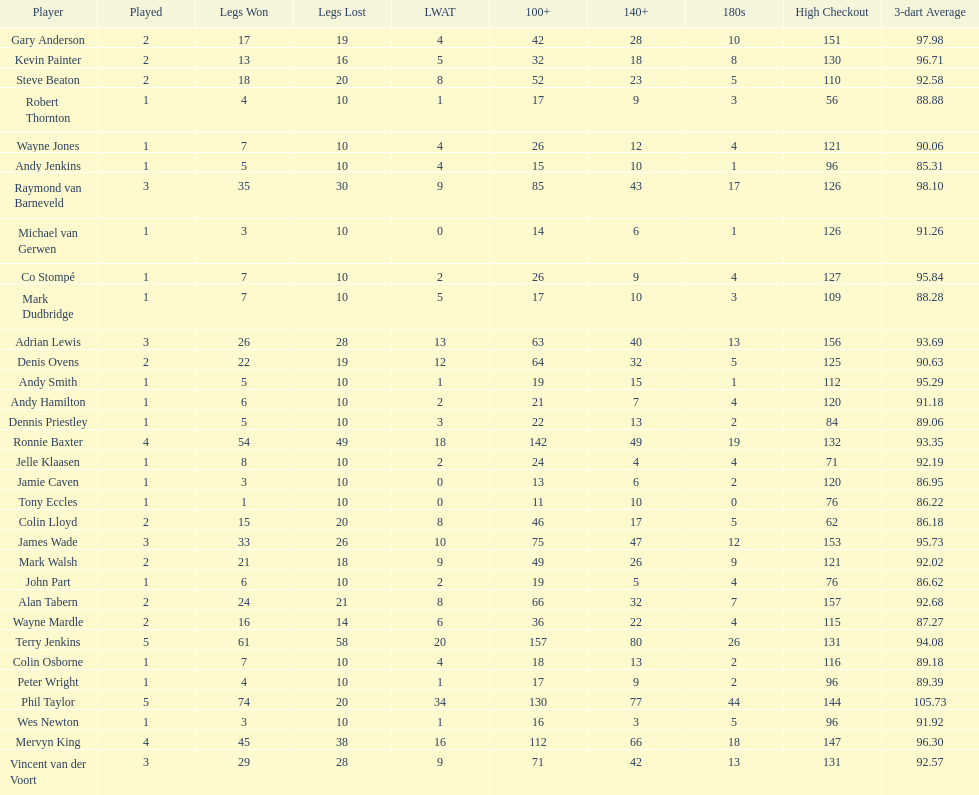How many players have a 3 dart average of more than 97? 3. 